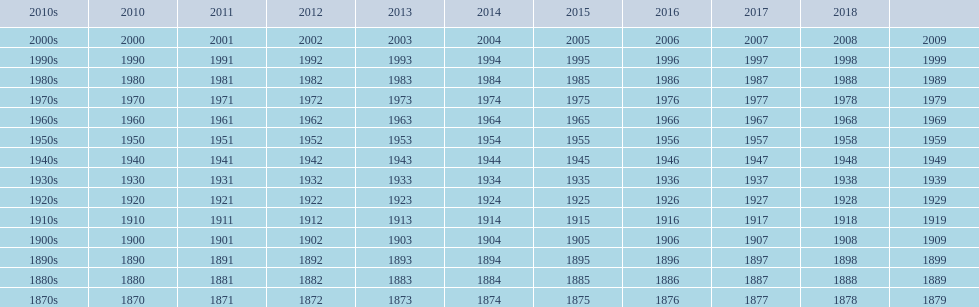Which decade is the only one to have fewer years in its row than the others? 2010s. 